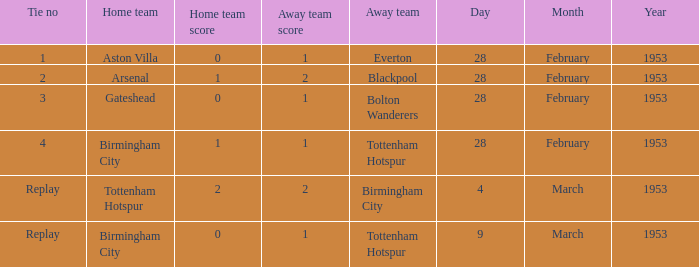When everton is the away team, which team is the home team? Aston Villa. Help me parse the entirety of this table. {'header': ['Tie no', 'Home team', 'Home team score', 'Away team score', 'Away team', 'Day', 'Month', 'Year'], 'rows': [['1', 'Aston Villa', '0', '1', 'Everton', '28', 'February', '1953'], ['2', 'Arsenal', '1', '2', 'Blackpool', '28', 'February', '1953'], ['3', 'Gateshead', '0', '1', 'Bolton Wanderers', '28', 'February', '1953'], ['4', 'Birmingham City', '1', '1', 'Tottenham Hotspur', '28', 'February', '1953'], ['Replay', 'Tottenham Hotspur', '2', '2', 'Birmingham City', '4', 'March', '1953'], ['Replay', 'Birmingham City', '0', '1', 'Tottenham Hotspur', '9', 'March', '1953']]} 